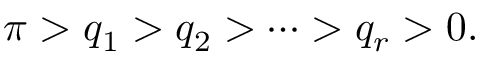<formula> <loc_0><loc_0><loc_500><loc_500>\pi > q _ { 1 } > q _ { 2 } > \cdots > q _ { r } > 0 .</formula> 